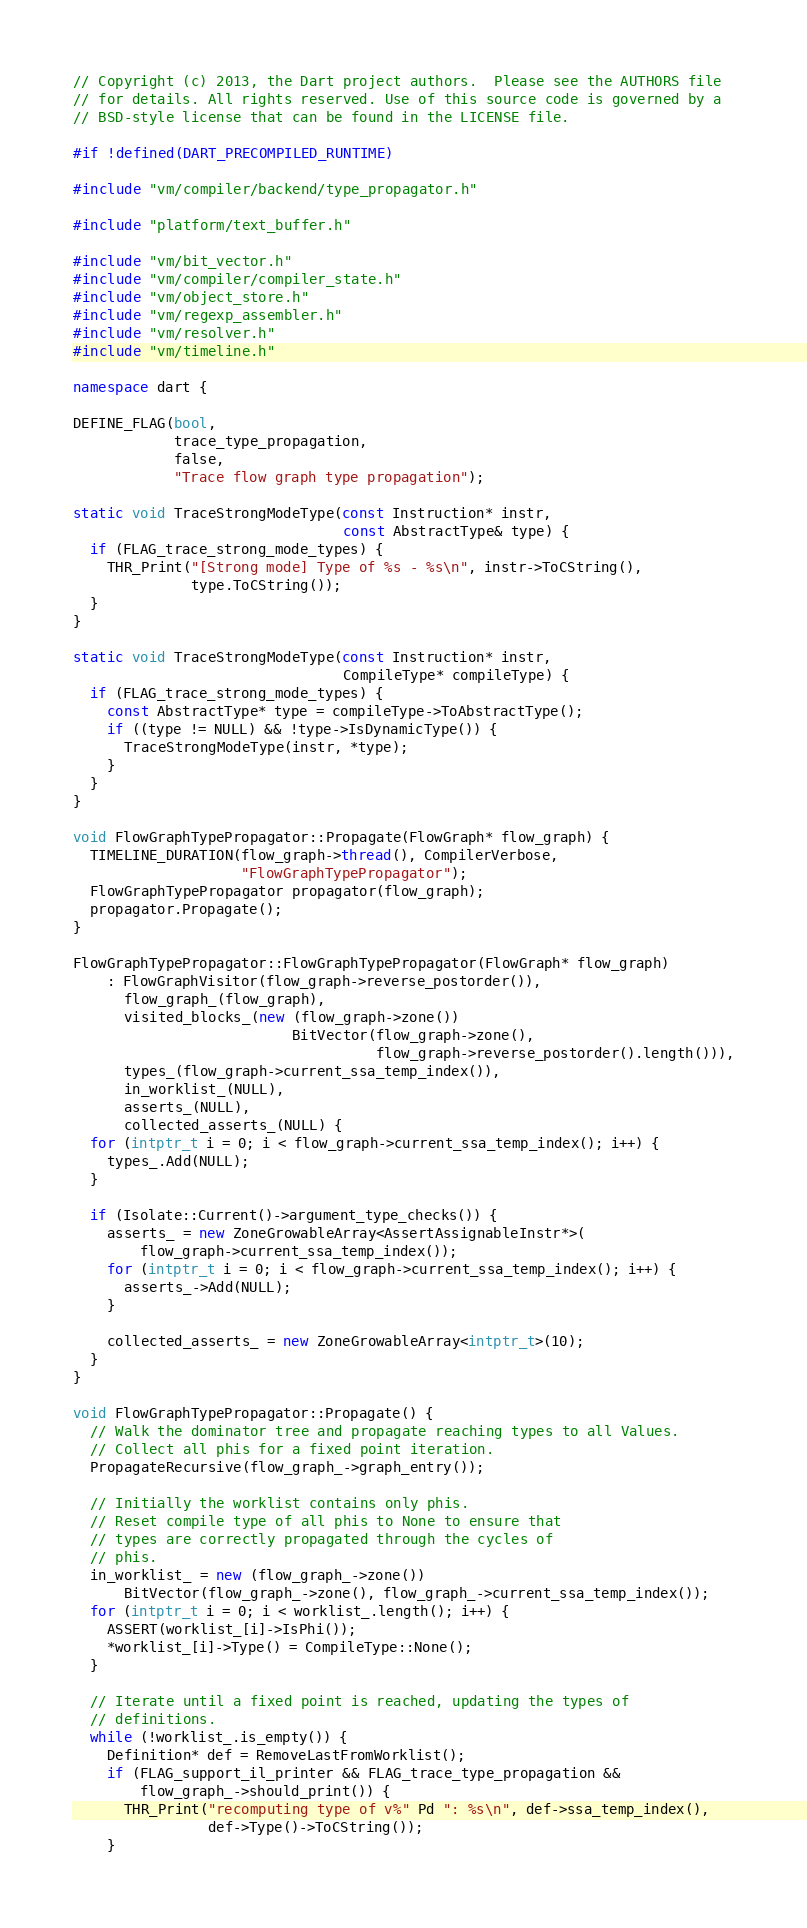Convert code to text. <code><loc_0><loc_0><loc_500><loc_500><_C++_>// Copyright (c) 2013, the Dart project authors.  Please see the AUTHORS file
// for details. All rights reserved. Use of this source code is governed by a
// BSD-style license that can be found in the LICENSE file.

#if !defined(DART_PRECOMPILED_RUNTIME)

#include "vm/compiler/backend/type_propagator.h"

#include "platform/text_buffer.h"

#include "vm/bit_vector.h"
#include "vm/compiler/compiler_state.h"
#include "vm/object_store.h"
#include "vm/regexp_assembler.h"
#include "vm/resolver.h"
#include "vm/timeline.h"

namespace dart {

DEFINE_FLAG(bool,
            trace_type_propagation,
            false,
            "Trace flow graph type propagation");

static void TraceStrongModeType(const Instruction* instr,
                                const AbstractType& type) {
  if (FLAG_trace_strong_mode_types) {
    THR_Print("[Strong mode] Type of %s - %s\n", instr->ToCString(),
              type.ToCString());
  }
}

static void TraceStrongModeType(const Instruction* instr,
                                CompileType* compileType) {
  if (FLAG_trace_strong_mode_types) {
    const AbstractType* type = compileType->ToAbstractType();
    if ((type != NULL) && !type->IsDynamicType()) {
      TraceStrongModeType(instr, *type);
    }
  }
}

void FlowGraphTypePropagator::Propagate(FlowGraph* flow_graph) {
  TIMELINE_DURATION(flow_graph->thread(), CompilerVerbose,
                    "FlowGraphTypePropagator");
  FlowGraphTypePropagator propagator(flow_graph);
  propagator.Propagate();
}

FlowGraphTypePropagator::FlowGraphTypePropagator(FlowGraph* flow_graph)
    : FlowGraphVisitor(flow_graph->reverse_postorder()),
      flow_graph_(flow_graph),
      visited_blocks_(new (flow_graph->zone())
                          BitVector(flow_graph->zone(),
                                    flow_graph->reverse_postorder().length())),
      types_(flow_graph->current_ssa_temp_index()),
      in_worklist_(NULL),
      asserts_(NULL),
      collected_asserts_(NULL) {
  for (intptr_t i = 0; i < flow_graph->current_ssa_temp_index(); i++) {
    types_.Add(NULL);
  }

  if (Isolate::Current()->argument_type_checks()) {
    asserts_ = new ZoneGrowableArray<AssertAssignableInstr*>(
        flow_graph->current_ssa_temp_index());
    for (intptr_t i = 0; i < flow_graph->current_ssa_temp_index(); i++) {
      asserts_->Add(NULL);
    }

    collected_asserts_ = new ZoneGrowableArray<intptr_t>(10);
  }
}

void FlowGraphTypePropagator::Propagate() {
  // Walk the dominator tree and propagate reaching types to all Values.
  // Collect all phis for a fixed point iteration.
  PropagateRecursive(flow_graph_->graph_entry());

  // Initially the worklist contains only phis.
  // Reset compile type of all phis to None to ensure that
  // types are correctly propagated through the cycles of
  // phis.
  in_worklist_ = new (flow_graph_->zone())
      BitVector(flow_graph_->zone(), flow_graph_->current_ssa_temp_index());
  for (intptr_t i = 0; i < worklist_.length(); i++) {
    ASSERT(worklist_[i]->IsPhi());
    *worklist_[i]->Type() = CompileType::None();
  }

  // Iterate until a fixed point is reached, updating the types of
  // definitions.
  while (!worklist_.is_empty()) {
    Definition* def = RemoveLastFromWorklist();
    if (FLAG_support_il_printer && FLAG_trace_type_propagation &&
        flow_graph_->should_print()) {
      THR_Print("recomputing type of v%" Pd ": %s\n", def->ssa_temp_index(),
                def->Type()->ToCString());
    }</code> 